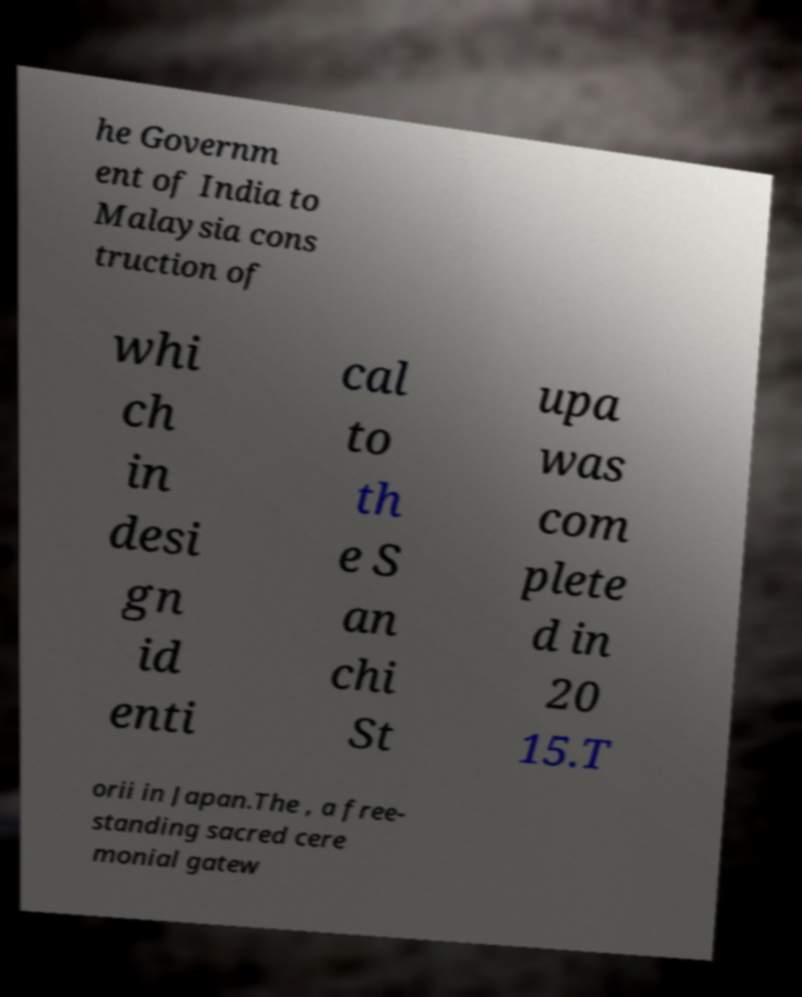Can you read and provide the text displayed in the image?This photo seems to have some interesting text. Can you extract and type it out for me? he Governm ent of India to Malaysia cons truction of whi ch in desi gn id enti cal to th e S an chi St upa was com plete d in 20 15.T orii in Japan.The , a free- standing sacred cere monial gatew 